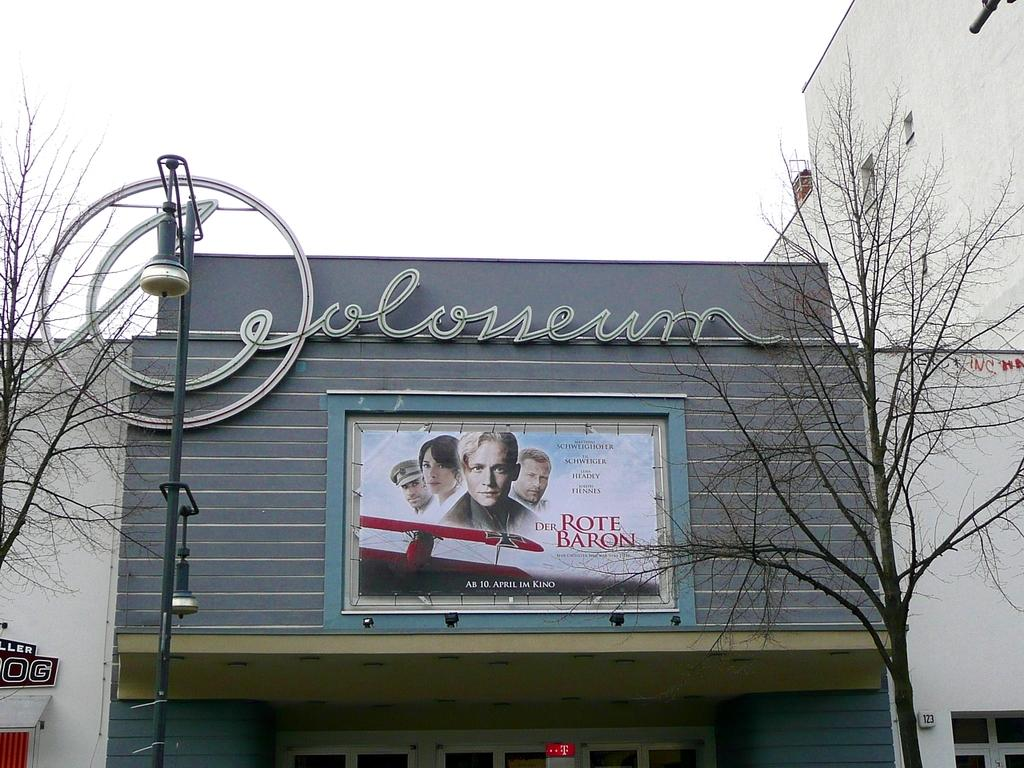What type of structure is present in the image? There is a building in the image. What can be seen in front of the building? Trees and a light pole are visible in front of the building. What is on the building itself? There are boards on the building. What is visible in the background of the image? The sky is visible in the background of the image. Can you see any mice running around in the image? There are no mice present in the image. 